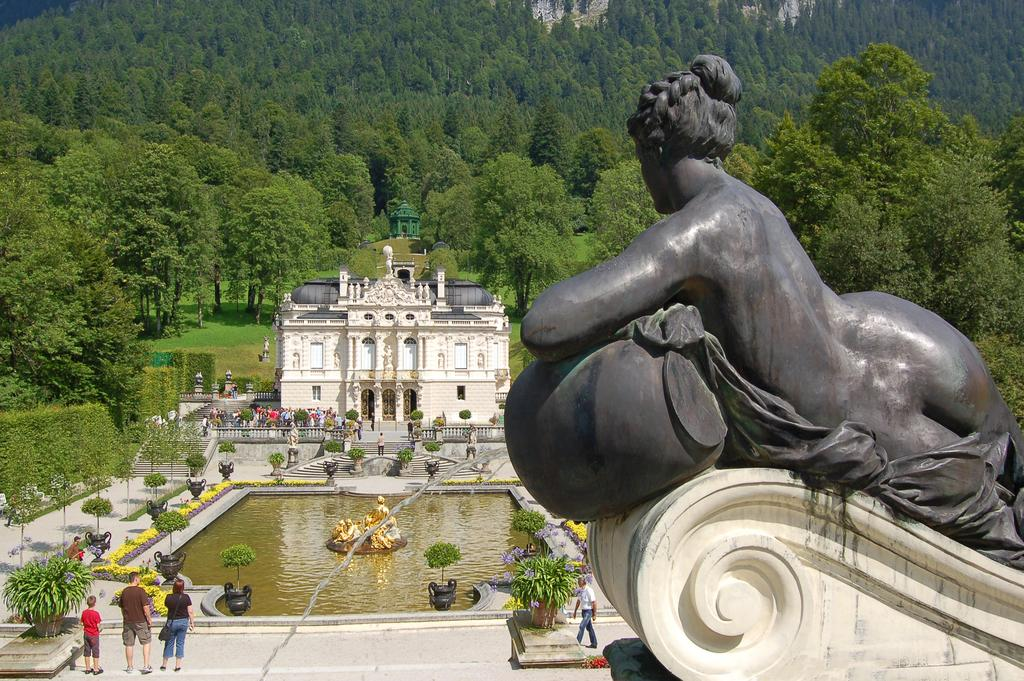What can be found in the right corner of the image? There is a statue in the right corner of the image. What is located in front of the statue? There are people and a building in front of the statue. What type of vegetation can be seen in the background of the image? There are trees present in the background of the image. What type of silk is draped over the statue in the image? There is no silk present in the image; the statue is not draped with any fabric. 